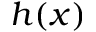<formula> <loc_0><loc_0><loc_500><loc_500>h ( x )</formula> 